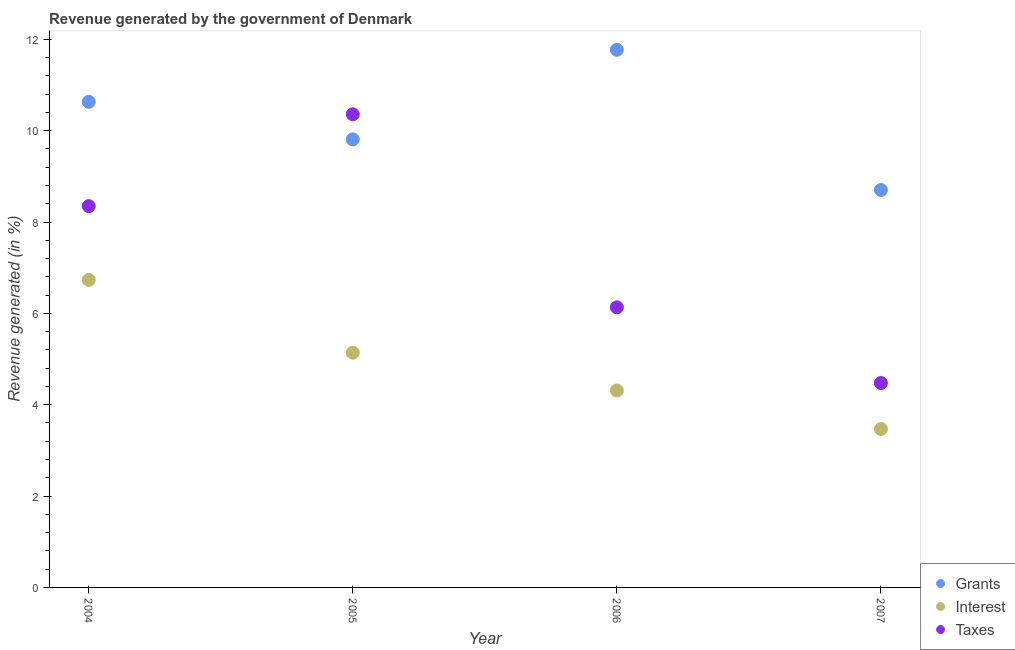How many different coloured dotlines are there?
Keep it short and to the point. 3. What is the percentage of revenue generated by interest in 2006?
Your answer should be compact. 4.31. Across all years, what is the maximum percentage of revenue generated by taxes?
Ensure brevity in your answer.  10.36. Across all years, what is the minimum percentage of revenue generated by taxes?
Keep it short and to the point. 4.47. In which year was the percentage of revenue generated by taxes maximum?
Ensure brevity in your answer.  2005. In which year was the percentage of revenue generated by grants minimum?
Provide a short and direct response. 2007. What is the total percentage of revenue generated by grants in the graph?
Your answer should be compact. 40.91. What is the difference between the percentage of revenue generated by taxes in 2004 and that in 2006?
Keep it short and to the point. 2.22. What is the difference between the percentage of revenue generated by interest in 2007 and the percentage of revenue generated by grants in 2005?
Ensure brevity in your answer.  -6.34. What is the average percentage of revenue generated by grants per year?
Provide a succinct answer. 10.23. In the year 2006, what is the difference between the percentage of revenue generated by grants and percentage of revenue generated by taxes?
Your answer should be very brief. 5.64. In how many years, is the percentage of revenue generated by interest greater than 7.6 %?
Keep it short and to the point. 0. What is the ratio of the percentage of revenue generated by grants in 2006 to that in 2007?
Your answer should be compact. 1.35. Is the difference between the percentage of revenue generated by grants in 2004 and 2007 greater than the difference between the percentage of revenue generated by interest in 2004 and 2007?
Your answer should be compact. No. What is the difference between the highest and the second highest percentage of revenue generated by grants?
Your response must be concise. 1.14. What is the difference between the highest and the lowest percentage of revenue generated by interest?
Your answer should be very brief. 3.27. Is it the case that in every year, the sum of the percentage of revenue generated by grants and percentage of revenue generated by interest is greater than the percentage of revenue generated by taxes?
Your answer should be compact. Yes. Does the percentage of revenue generated by interest monotonically increase over the years?
Offer a terse response. No. Is the percentage of revenue generated by taxes strictly greater than the percentage of revenue generated by interest over the years?
Make the answer very short. Yes. How many dotlines are there?
Your answer should be compact. 3. How many years are there in the graph?
Your answer should be compact. 4. Does the graph contain grids?
Your answer should be very brief. No. Where does the legend appear in the graph?
Offer a very short reply. Bottom right. How are the legend labels stacked?
Your answer should be very brief. Vertical. What is the title of the graph?
Provide a succinct answer. Revenue generated by the government of Denmark. Does "Transport" appear as one of the legend labels in the graph?
Provide a succinct answer. No. What is the label or title of the X-axis?
Provide a succinct answer. Year. What is the label or title of the Y-axis?
Provide a succinct answer. Revenue generated (in %). What is the Revenue generated (in %) of Grants in 2004?
Ensure brevity in your answer.  10.63. What is the Revenue generated (in %) of Interest in 2004?
Offer a very short reply. 6.73. What is the Revenue generated (in %) of Taxes in 2004?
Provide a succinct answer. 8.35. What is the Revenue generated (in %) of Grants in 2005?
Provide a short and direct response. 9.81. What is the Revenue generated (in %) of Interest in 2005?
Your answer should be compact. 5.14. What is the Revenue generated (in %) in Taxes in 2005?
Provide a succinct answer. 10.36. What is the Revenue generated (in %) of Grants in 2006?
Your answer should be compact. 11.77. What is the Revenue generated (in %) of Interest in 2006?
Ensure brevity in your answer.  4.31. What is the Revenue generated (in %) in Taxes in 2006?
Offer a terse response. 6.13. What is the Revenue generated (in %) of Grants in 2007?
Provide a short and direct response. 8.7. What is the Revenue generated (in %) in Interest in 2007?
Your answer should be compact. 3.47. What is the Revenue generated (in %) of Taxes in 2007?
Ensure brevity in your answer.  4.47. Across all years, what is the maximum Revenue generated (in %) in Grants?
Offer a terse response. 11.77. Across all years, what is the maximum Revenue generated (in %) in Interest?
Offer a terse response. 6.73. Across all years, what is the maximum Revenue generated (in %) in Taxes?
Keep it short and to the point. 10.36. Across all years, what is the minimum Revenue generated (in %) in Grants?
Your answer should be very brief. 8.7. Across all years, what is the minimum Revenue generated (in %) in Interest?
Your answer should be compact. 3.47. Across all years, what is the minimum Revenue generated (in %) of Taxes?
Your response must be concise. 4.47. What is the total Revenue generated (in %) of Grants in the graph?
Your answer should be compact. 40.91. What is the total Revenue generated (in %) in Interest in the graph?
Your response must be concise. 19.65. What is the total Revenue generated (in %) of Taxes in the graph?
Offer a terse response. 29.31. What is the difference between the Revenue generated (in %) of Grants in 2004 and that in 2005?
Your answer should be very brief. 0.82. What is the difference between the Revenue generated (in %) of Interest in 2004 and that in 2005?
Offer a terse response. 1.59. What is the difference between the Revenue generated (in %) of Taxes in 2004 and that in 2005?
Your response must be concise. -2.01. What is the difference between the Revenue generated (in %) of Grants in 2004 and that in 2006?
Make the answer very short. -1.14. What is the difference between the Revenue generated (in %) in Interest in 2004 and that in 2006?
Offer a terse response. 2.42. What is the difference between the Revenue generated (in %) of Taxes in 2004 and that in 2006?
Your answer should be compact. 2.22. What is the difference between the Revenue generated (in %) of Grants in 2004 and that in 2007?
Give a very brief answer. 1.93. What is the difference between the Revenue generated (in %) in Interest in 2004 and that in 2007?
Ensure brevity in your answer.  3.27. What is the difference between the Revenue generated (in %) in Taxes in 2004 and that in 2007?
Your response must be concise. 3.87. What is the difference between the Revenue generated (in %) in Grants in 2005 and that in 2006?
Offer a very short reply. -1.96. What is the difference between the Revenue generated (in %) of Interest in 2005 and that in 2006?
Offer a very short reply. 0.83. What is the difference between the Revenue generated (in %) in Taxes in 2005 and that in 2006?
Your response must be concise. 4.23. What is the difference between the Revenue generated (in %) in Grants in 2005 and that in 2007?
Give a very brief answer. 1.11. What is the difference between the Revenue generated (in %) of Interest in 2005 and that in 2007?
Provide a succinct answer. 1.67. What is the difference between the Revenue generated (in %) in Taxes in 2005 and that in 2007?
Make the answer very short. 5.88. What is the difference between the Revenue generated (in %) of Grants in 2006 and that in 2007?
Your response must be concise. 3.07. What is the difference between the Revenue generated (in %) in Interest in 2006 and that in 2007?
Provide a short and direct response. 0.84. What is the difference between the Revenue generated (in %) of Taxes in 2006 and that in 2007?
Keep it short and to the point. 1.66. What is the difference between the Revenue generated (in %) of Grants in 2004 and the Revenue generated (in %) of Interest in 2005?
Offer a terse response. 5.49. What is the difference between the Revenue generated (in %) in Grants in 2004 and the Revenue generated (in %) in Taxes in 2005?
Your answer should be compact. 0.27. What is the difference between the Revenue generated (in %) in Interest in 2004 and the Revenue generated (in %) in Taxes in 2005?
Your response must be concise. -3.62. What is the difference between the Revenue generated (in %) of Grants in 2004 and the Revenue generated (in %) of Interest in 2006?
Offer a very short reply. 6.32. What is the difference between the Revenue generated (in %) of Grants in 2004 and the Revenue generated (in %) of Taxes in 2006?
Ensure brevity in your answer.  4.5. What is the difference between the Revenue generated (in %) in Interest in 2004 and the Revenue generated (in %) in Taxes in 2006?
Offer a terse response. 0.6. What is the difference between the Revenue generated (in %) in Grants in 2004 and the Revenue generated (in %) in Interest in 2007?
Make the answer very short. 7.16. What is the difference between the Revenue generated (in %) of Grants in 2004 and the Revenue generated (in %) of Taxes in 2007?
Provide a short and direct response. 6.16. What is the difference between the Revenue generated (in %) of Interest in 2004 and the Revenue generated (in %) of Taxes in 2007?
Offer a very short reply. 2.26. What is the difference between the Revenue generated (in %) in Grants in 2005 and the Revenue generated (in %) in Interest in 2006?
Provide a short and direct response. 5.5. What is the difference between the Revenue generated (in %) in Grants in 2005 and the Revenue generated (in %) in Taxes in 2006?
Your response must be concise. 3.68. What is the difference between the Revenue generated (in %) in Interest in 2005 and the Revenue generated (in %) in Taxes in 2006?
Offer a terse response. -0.99. What is the difference between the Revenue generated (in %) in Grants in 2005 and the Revenue generated (in %) in Interest in 2007?
Provide a succinct answer. 6.34. What is the difference between the Revenue generated (in %) in Grants in 2005 and the Revenue generated (in %) in Taxes in 2007?
Your response must be concise. 5.33. What is the difference between the Revenue generated (in %) of Interest in 2005 and the Revenue generated (in %) of Taxes in 2007?
Offer a terse response. 0.66. What is the difference between the Revenue generated (in %) of Grants in 2006 and the Revenue generated (in %) of Interest in 2007?
Give a very brief answer. 8.3. What is the difference between the Revenue generated (in %) of Grants in 2006 and the Revenue generated (in %) of Taxes in 2007?
Provide a short and direct response. 7.3. What is the difference between the Revenue generated (in %) in Interest in 2006 and the Revenue generated (in %) in Taxes in 2007?
Give a very brief answer. -0.16. What is the average Revenue generated (in %) in Grants per year?
Provide a succinct answer. 10.23. What is the average Revenue generated (in %) in Interest per year?
Ensure brevity in your answer.  4.91. What is the average Revenue generated (in %) of Taxes per year?
Your answer should be compact. 7.33. In the year 2004, what is the difference between the Revenue generated (in %) in Grants and Revenue generated (in %) in Interest?
Your answer should be very brief. 3.9. In the year 2004, what is the difference between the Revenue generated (in %) of Grants and Revenue generated (in %) of Taxes?
Your answer should be very brief. 2.28. In the year 2004, what is the difference between the Revenue generated (in %) in Interest and Revenue generated (in %) in Taxes?
Provide a succinct answer. -1.61. In the year 2005, what is the difference between the Revenue generated (in %) in Grants and Revenue generated (in %) in Interest?
Ensure brevity in your answer.  4.67. In the year 2005, what is the difference between the Revenue generated (in %) in Grants and Revenue generated (in %) in Taxes?
Your answer should be compact. -0.55. In the year 2005, what is the difference between the Revenue generated (in %) of Interest and Revenue generated (in %) of Taxes?
Make the answer very short. -5.22. In the year 2006, what is the difference between the Revenue generated (in %) of Grants and Revenue generated (in %) of Interest?
Ensure brevity in your answer.  7.46. In the year 2006, what is the difference between the Revenue generated (in %) in Grants and Revenue generated (in %) in Taxes?
Offer a terse response. 5.64. In the year 2006, what is the difference between the Revenue generated (in %) in Interest and Revenue generated (in %) in Taxes?
Your response must be concise. -1.82. In the year 2007, what is the difference between the Revenue generated (in %) of Grants and Revenue generated (in %) of Interest?
Offer a very short reply. 5.23. In the year 2007, what is the difference between the Revenue generated (in %) in Grants and Revenue generated (in %) in Taxes?
Provide a succinct answer. 4.23. In the year 2007, what is the difference between the Revenue generated (in %) in Interest and Revenue generated (in %) in Taxes?
Offer a very short reply. -1.01. What is the ratio of the Revenue generated (in %) in Grants in 2004 to that in 2005?
Make the answer very short. 1.08. What is the ratio of the Revenue generated (in %) in Interest in 2004 to that in 2005?
Offer a very short reply. 1.31. What is the ratio of the Revenue generated (in %) of Taxes in 2004 to that in 2005?
Provide a succinct answer. 0.81. What is the ratio of the Revenue generated (in %) in Grants in 2004 to that in 2006?
Ensure brevity in your answer.  0.9. What is the ratio of the Revenue generated (in %) of Interest in 2004 to that in 2006?
Offer a very short reply. 1.56. What is the ratio of the Revenue generated (in %) in Taxes in 2004 to that in 2006?
Provide a succinct answer. 1.36. What is the ratio of the Revenue generated (in %) in Grants in 2004 to that in 2007?
Offer a very short reply. 1.22. What is the ratio of the Revenue generated (in %) of Interest in 2004 to that in 2007?
Make the answer very short. 1.94. What is the ratio of the Revenue generated (in %) in Taxes in 2004 to that in 2007?
Provide a succinct answer. 1.87. What is the ratio of the Revenue generated (in %) of Grants in 2005 to that in 2006?
Your answer should be very brief. 0.83. What is the ratio of the Revenue generated (in %) in Interest in 2005 to that in 2006?
Provide a succinct answer. 1.19. What is the ratio of the Revenue generated (in %) of Taxes in 2005 to that in 2006?
Provide a succinct answer. 1.69. What is the ratio of the Revenue generated (in %) of Grants in 2005 to that in 2007?
Your answer should be very brief. 1.13. What is the ratio of the Revenue generated (in %) in Interest in 2005 to that in 2007?
Ensure brevity in your answer.  1.48. What is the ratio of the Revenue generated (in %) in Taxes in 2005 to that in 2007?
Your response must be concise. 2.31. What is the ratio of the Revenue generated (in %) of Grants in 2006 to that in 2007?
Your answer should be compact. 1.35. What is the ratio of the Revenue generated (in %) in Interest in 2006 to that in 2007?
Provide a succinct answer. 1.24. What is the ratio of the Revenue generated (in %) in Taxes in 2006 to that in 2007?
Give a very brief answer. 1.37. What is the difference between the highest and the second highest Revenue generated (in %) in Grants?
Your response must be concise. 1.14. What is the difference between the highest and the second highest Revenue generated (in %) in Interest?
Provide a short and direct response. 1.59. What is the difference between the highest and the second highest Revenue generated (in %) in Taxes?
Give a very brief answer. 2.01. What is the difference between the highest and the lowest Revenue generated (in %) in Grants?
Ensure brevity in your answer.  3.07. What is the difference between the highest and the lowest Revenue generated (in %) in Interest?
Keep it short and to the point. 3.27. What is the difference between the highest and the lowest Revenue generated (in %) in Taxes?
Offer a very short reply. 5.88. 